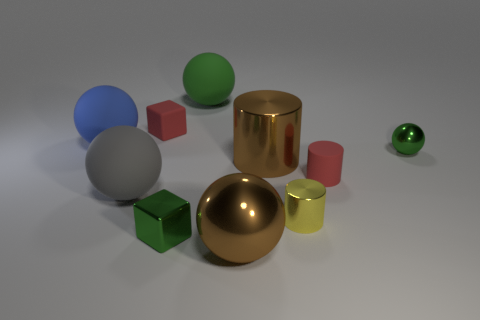Subtract all gray balls. How many balls are left? 4 Add 4 large brown shiny spheres. How many large brown shiny spheres are left? 5 Add 1 metallic cylinders. How many metallic cylinders exist? 3 Subtract all brown balls. How many balls are left? 4 Subtract 1 red blocks. How many objects are left? 9 Subtract all cylinders. How many objects are left? 7 Subtract 3 spheres. How many spheres are left? 2 Subtract all green cylinders. Subtract all red blocks. How many cylinders are left? 3 Subtract all blue blocks. How many blue spheres are left? 1 Subtract all blue spheres. Subtract all gray matte balls. How many objects are left? 8 